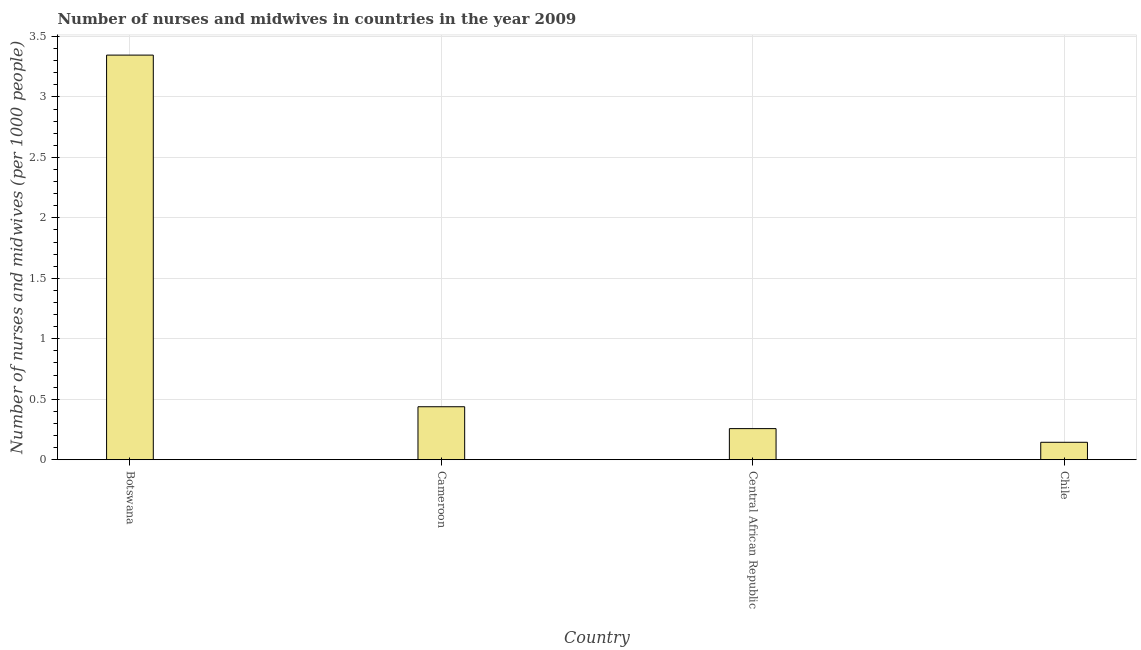Does the graph contain any zero values?
Your answer should be very brief. No. What is the title of the graph?
Provide a short and direct response. Number of nurses and midwives in countries in the year 2009. What is the label or title of the Y-axis?
Your answer should be very brief. Number of nurses and midwives (per 1000 people). What is the number of nurses and midwives in Botswana?
Offer a very short reply. 3.35. Across all countries, what is the maximum number of nurses and midwives?
Offer a terse response. 3.35. Across all countries, what is the minimum number of nurses and midwives?
Offer a very short reply. 0.14. In which country was the number of nurses and midwives maximum?
Your answer should be compact. Botswana. What is the sum of the number of nurses and midwives?
Keep it short and to the point. 4.19. What is the difference between the number of nurses and midwives in Cameroon and Chile?
Your answer should be very brief. 0.29. What is the average number of nurses and midwives per country?
Provide a short and direct response. 1.05. What is the median number of nurses and midwives?
Keep it short and to the point. 0.35. In how many countries, is the number of nurses and midwives greater than 1.2 ?
Your answer should be compact. 1. What is the ratio of the number of nurses and midwives in Central African Republic to that in Chile?
Ensure brevity in your answer.  1.78. Is the difference between the number of nurses and midwives in Botswana and Chile greater than the difference between any two countries?
Provide a short and direct response. Yes. What is the difference between the highest and the second highest number of nurses and midwives?
Give a very brief answer. 2.91. What is the difference between the highest and the lowest number of nurses and midwives?
Keep it short and to the point. 3.2. How many bars are there?
Provide a short and direct response. 4. Are all the bars in the graph horizontal?
Offer a terse response. No. Are the values on the major ticks of Y-axis written in scientific E-notation?
Give a very brief answer. No. What is the Number of nurses and midwives (per 1000 people) of Botswana?
Keep it short and to the point. 3.35. What is the Number of nurses and midwives (per 1000 people) of Cameroon?
Offer a terse response. 0.44. What is the Number of nurses and midwives (per 1000 people) of Central African Republic?
Offer a terse response. 0.26. What is the Number of nurses and midwives (per 1000 people) of Chile?
Provide a succinct answer. 0.14. What is the difference between the Number of nurses and midwives (per 1000 people) in Botswana and Cameroon?
Provide a succinct answer. 2.91. What is the difference between the Number of nurses and midwives (per 1000 people) in Botswana and Central African Republic?
Your answer should be compact. 3.09. What is the difference between the Number of nurses and midwives (per 1000 people) in Botswana and Chile?
Provide a short and direct response. 3.2. What is the difference between the Number of nurses and midwives (per 1000 people) in Cameroon and Central African Republic?
Offer a terse response. 0.18. What is the difference between the Number of nurses and midwives (per 1000 people) in Cameroon and Chile?
Keep it short and to the point. 0.29. What is the difference between the Number of nurses and midwives (per 1000 people) in Central African Republic and Chile?
Give a very brief answer. 0.11. What is the ratio of the Number of nurses and midwives (per 1000 people) in Botswana to that in Cameroon?
Offer a terse response. 7.64. What is the ratio of the Number of nurses and midwives (per 1000 people) in Botswana to that in Central African Republic?
Ensure brevity in your answer.  13.02. What is the ratio of the Number of nurses and midwives (per 1000 people) in Botswana to that in Chile?
Your answer should be compact. 23.24. What is the ratio of the Number of nurses and midwives (per 1000 people) in Cameroon to that in Central African Republic?
Give a very brief answer. 1.7. What is the ratio of the Number of nurses and midwives (per 1000 people) in Cameroon to that in Chile?
Your answer should be very brief. 3.04. What is the ratio of the Number of nurses and midwives (per 1000 people) in Central African Republic to that in Chile?
Offer a very short reply. 1.78. 